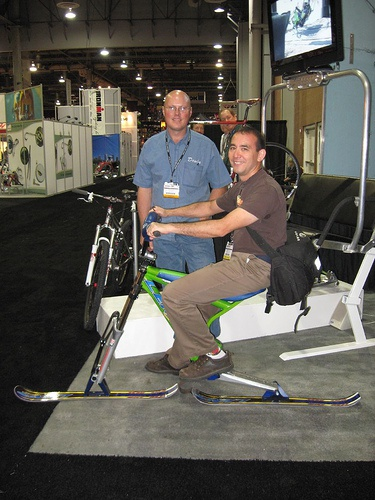Describe the objects in this image and their specific colors. I can see people in black and gray tones, people in black, gray, and salmon tones, tv in black, white, gray, and darkblue tones, bicycle in black, gray, lightgray, and darkgray tones, and backpack in black, gray, and white tones in this image. 